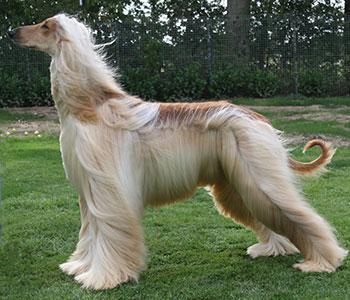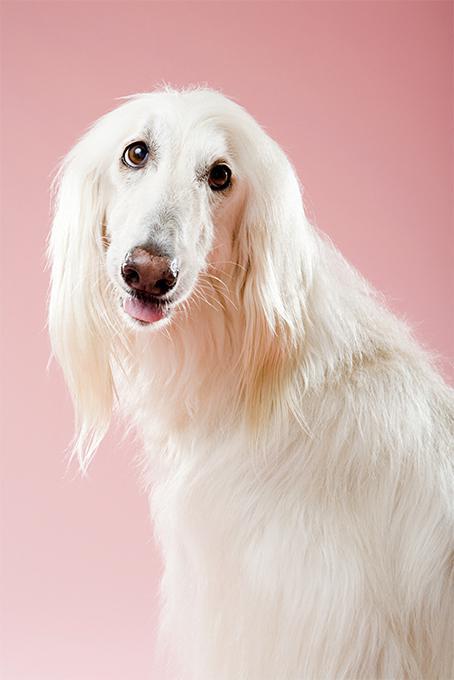The first image is the image on the left, the second image is the image on the right. Considering the images on both sides, is "In one image there is a lone afghan hound standing outside and facing the left side of the image." valid? Answer yes or no. Yes. The first image is the image on the left, the second image is the image on the right. Given the left and right images, does the statement "At least one image is of a dog from the shoulders up, looking toward the camera." hold true? Answer yes or no. Yes. 